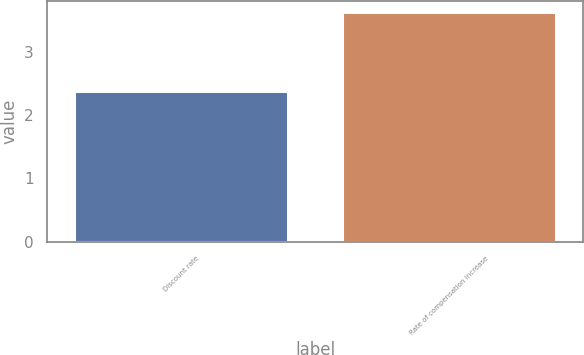Convert chart to OTSL. <chart><loc_0><loc_0><loc_500><loc_500><bar_chart><fcel>Discount rate<fcel>Rate of compensation increase<nl><fcel>2.38<fcel>3.63<nl></chart> 